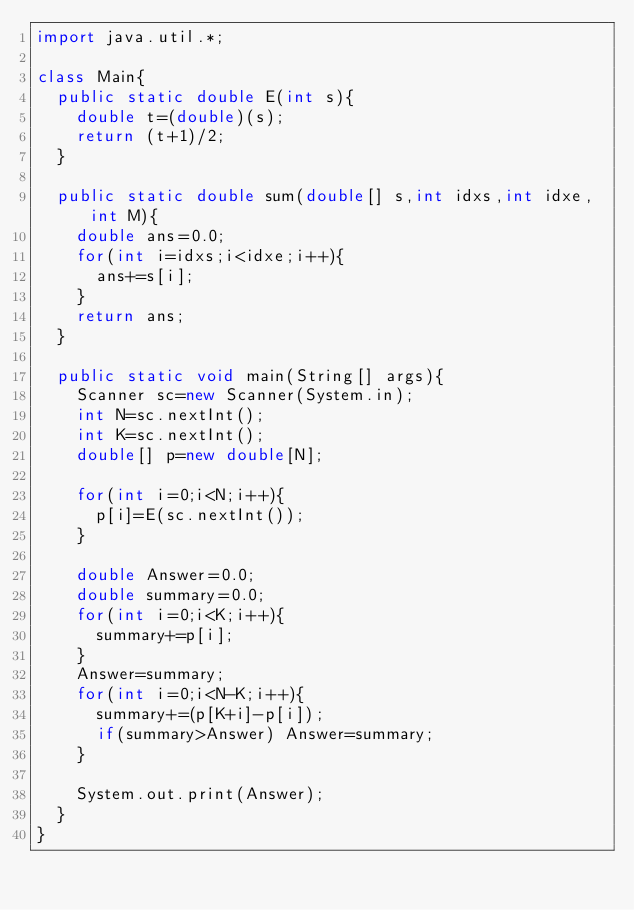<code> <loc_0><loc_0><loc_500><loc_500><_Java_>import java.util.*;

class Main{
  public static double E(int s){
    double t=(double)(s);
    return (t+1)/2;
  }
  
  public static double sum(double[] s,int idxs,int idxe,int M){
    double ans=0.0;
    for(int i=idxs;i<idxe;i++){
      ans+=s[i];
    }
    return ans;
  }
  
  public static void main(String[] args){
    Scanner sc=new Scanner(System.in);
    int N=sc.nextInt();
    int K=sc.nextInt();
    double[] p=new double[N];
    
    for(int i=0;i<N;i++){
      p[i]=E(sc.nextInt());
    }
    
    double Answer=0.0;
    double summary=0.0;
    for(int i=0;i<K;i++){
      summary+=p[i];
    }
    Answer=summary;
    for(int i=0;i<N-K;i++){
      summary+=(p[K+i]-p[i]);
      if(summary>Answer) Answer=summary;
    }
    
    System.out.print(Answer);
  }
}
</code> 